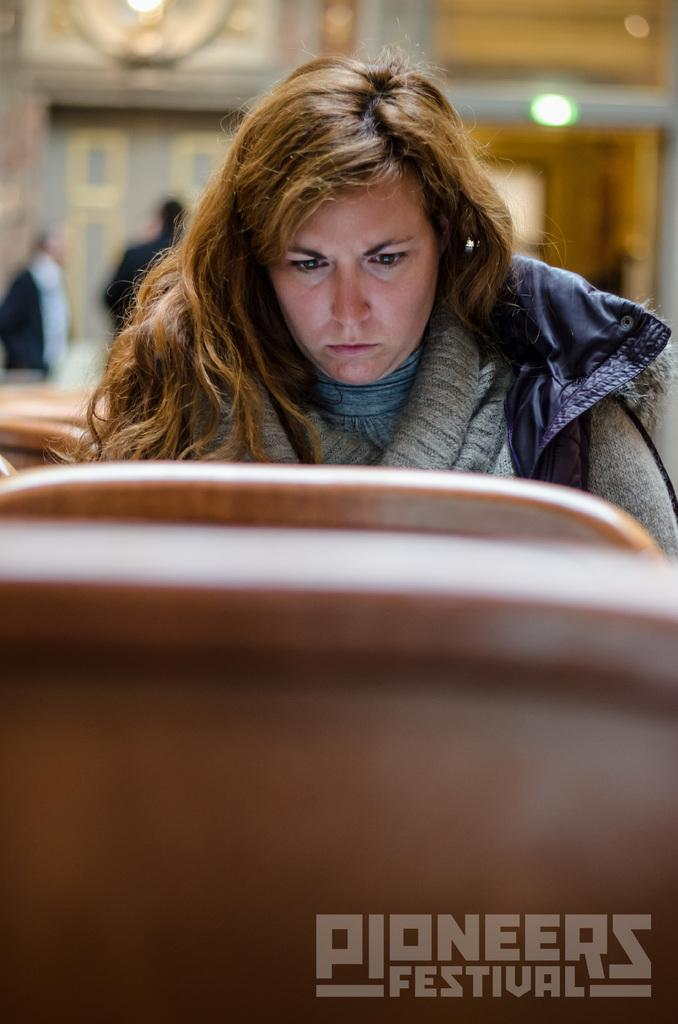What is the woman in the image doing? The woman is sitting in the image. What can be found at the bottom of the image? There is text at the bottom of the image. Can you describe the people in the image? There are people standing on the backside of the image. What type of whistle can be heard in the image? There is no whistle present in the image, and therefore no sound can be heard. 